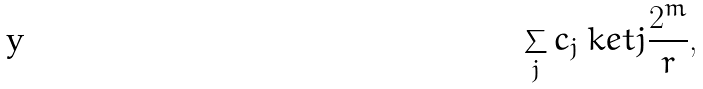Convert formula to latex. <formula><loc_0><loc_0><loc_500><loc_500>\sum _ { j } c _ { j } \ k e t { j \frac { 2 ^ { m } } { r } } ,</formula> 